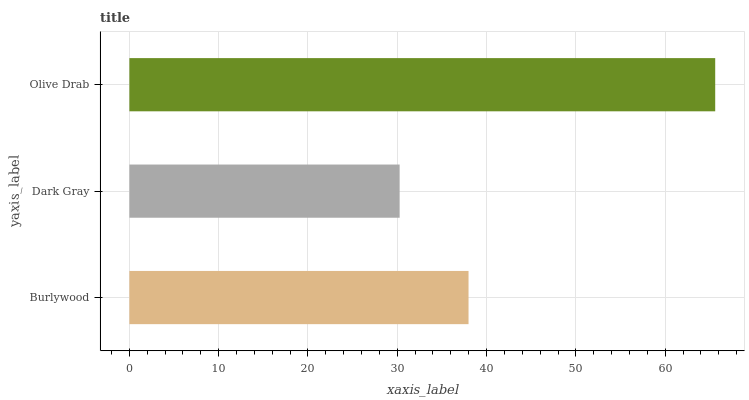Is Dark Gray the minimum?
Answer yes or no. Yes. Is Olive Drab the maximum?
Answer yes or no. Yes. Is Olive Drab the minimum?
Answer yes or no. No. Is Dark Gray the maximum?
Answer yes or no. No. Is Olive Drab greater than Dark Gray?
Answer yes or no. Yes. Is Dark Gray less than Olive Drab?
Answer yes or no. Yes. Is Dark Gray greater than Olive Drab?
Answer yes or no. No. Is Olive Drab less than Dark Gray?
Answer yes or no. No. Is Burlywood the high median?
Answer yes or no. Yes. Is Burlywood the low median?
Answer yes or no. Yes. Is Olive Drab the high median?
Answer yes or no. No. Is Dark Gray the low median?
Answer yes or no. No. 